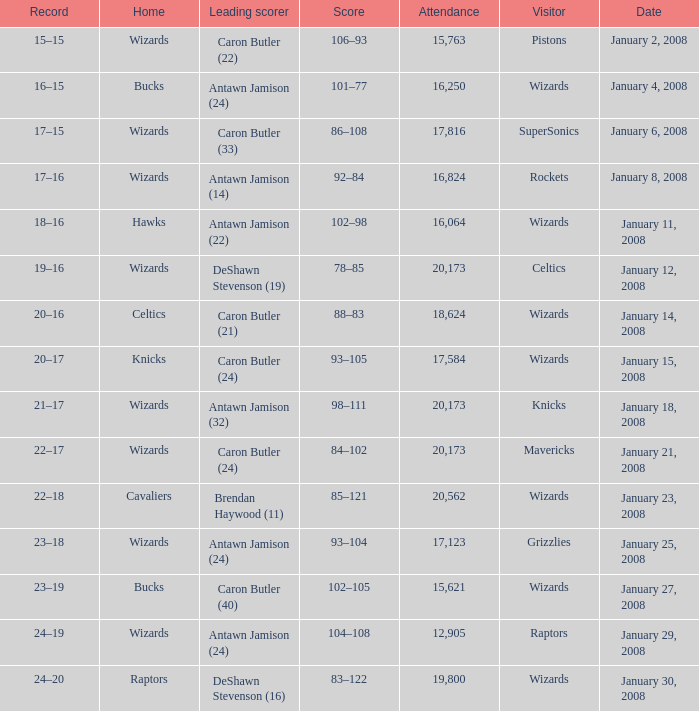How many people were in attendance on January 4, 2008? 16250.0. 